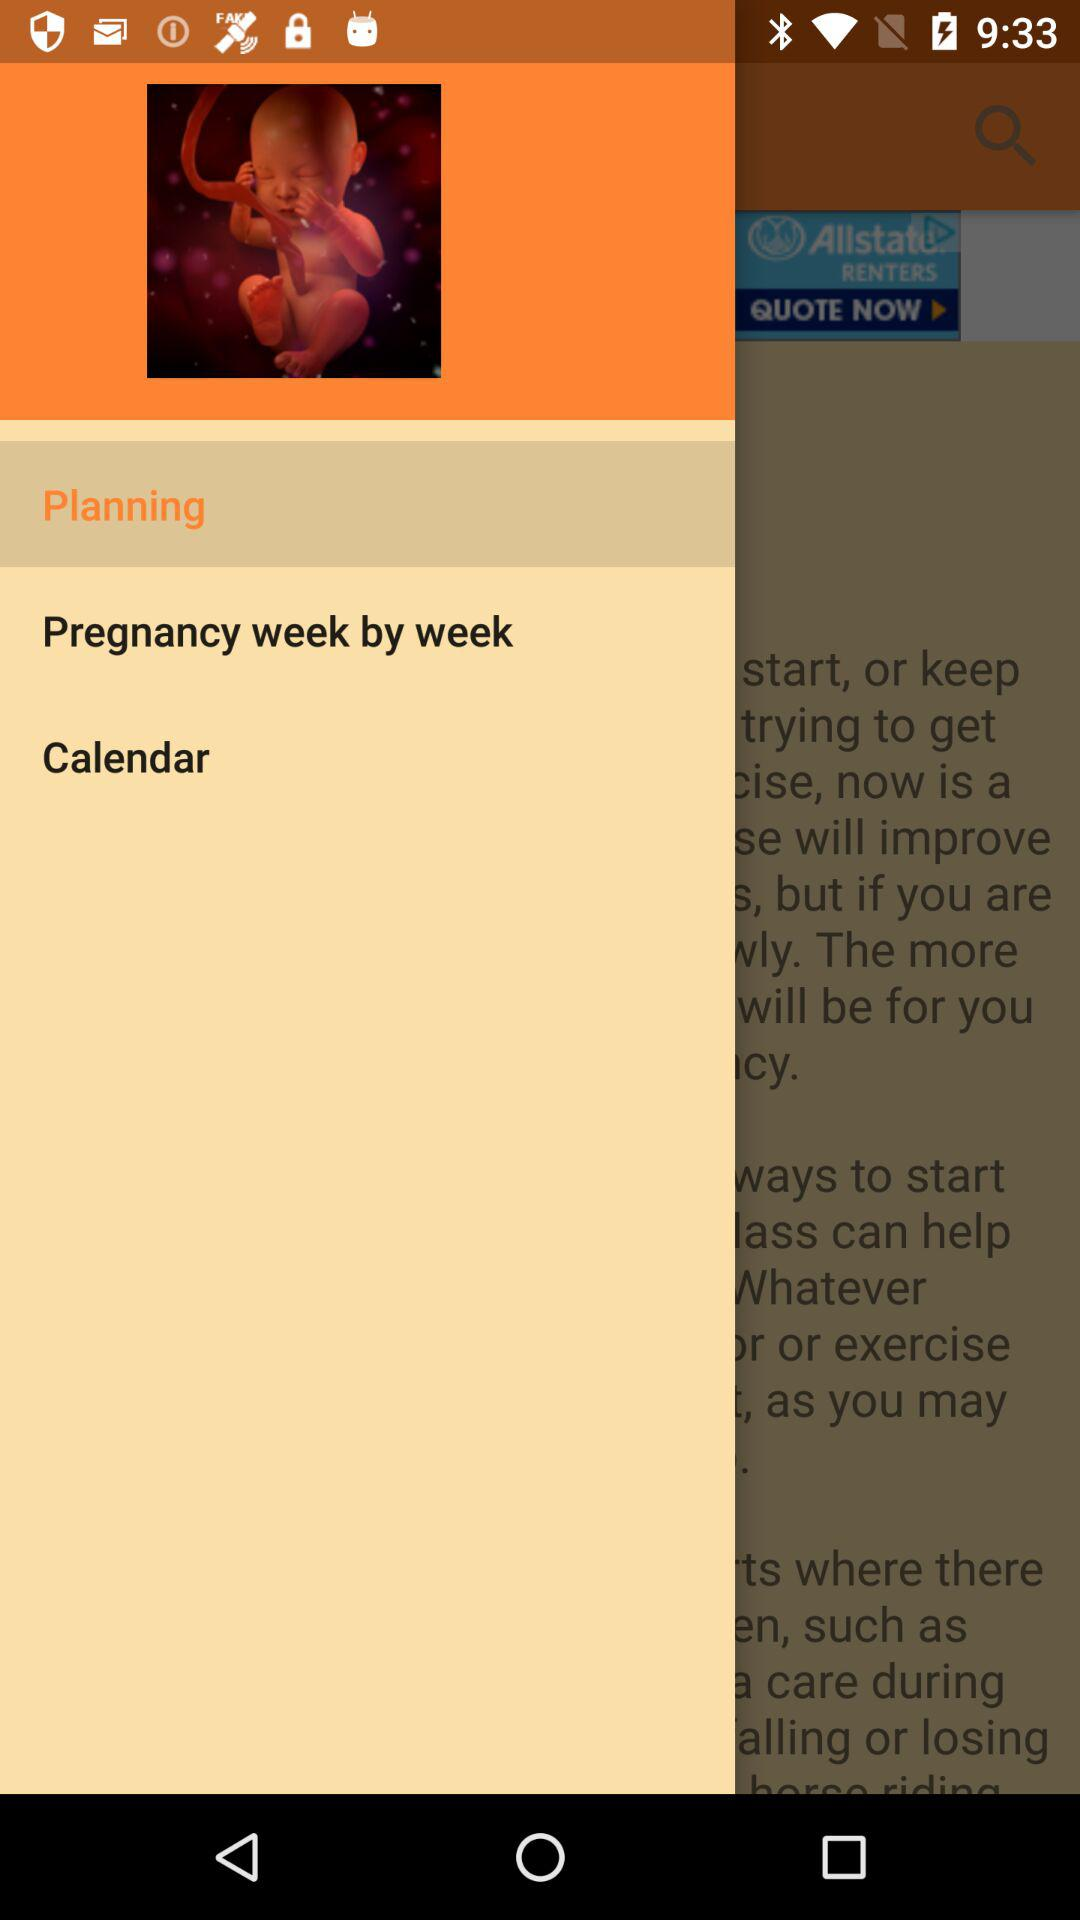Which option is selected? The selected option is "Planning". 